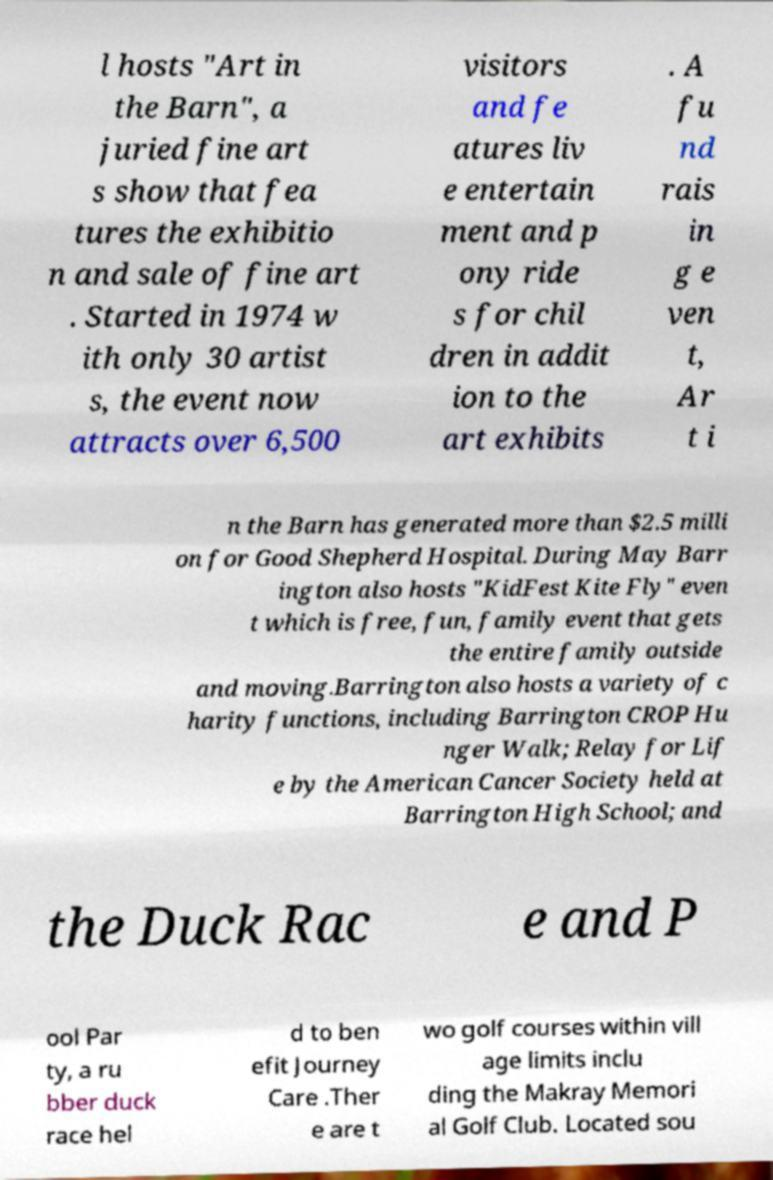Could you assist in decoding the text presented in this image and type it out clearly? l hosts "Art in the Barn", a juried fine art s show that fea tures the exhibitio n and sale of fine art . Started in 1974 w ith only 30 artist s, the event now attracts over 6,500 visitors and fe atures liv e entertain ment and p ony ride s for chil dren in addit ion to the art exhibits . A fu nd rais in g e ven t, Ar t i n the Barn has generated more than $2.5 milli on for Good Shepherd Hospital. During May Barr ington also hosts "KidFest Kite Fly" even t which is free, fun, family event that gets the entire family outside and moving.Barrington also hosts a variety of c harity functions, including Barrington CROP Hu nger Walk; Relay for Lif e by the American Cancer Society held at Barrington High School; and the Duck Rac e and P ool Par ty, a ru bber duck race hel d to ben efit Journey Care .Ther e are t wo golf courses within vill age limits inclu ding the Makray Memori al Golf Club. Located sou 